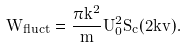Convert formula to latex. <formula><loc_0><loc_0><loc_500><loc_500>\dot { W } _ { f l u c t } = \frac { \pi k ^ { 2 } } { m } U _ { 0 } ^ { 2 } S _ { c } ( 2 k v ) .</formula> 